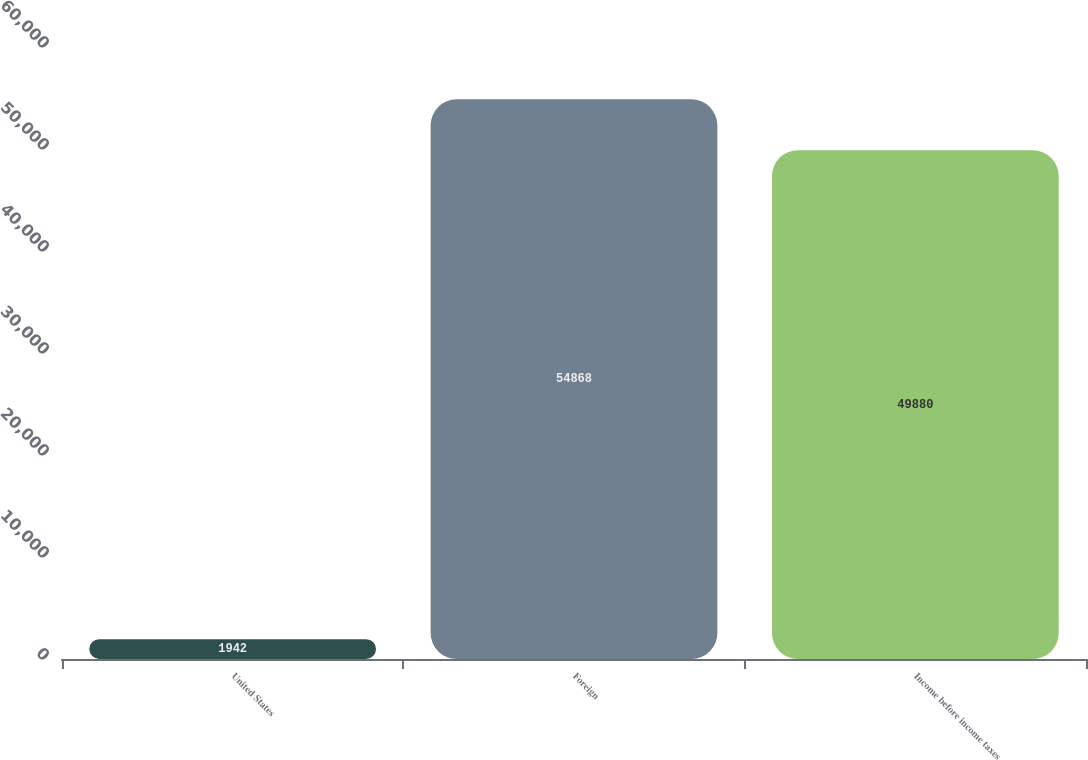Convert chart to OTSL. <chart><loc_0><loc_0><loc_500><loc_500><bar_chart><fcel>United States<fcel>Foreign<fcel>Income before income taxes<nl><fcel>1942<fcel>54868<fcel>49880<nl></chart> 